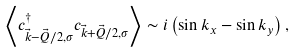<formula> <loc_0><loc_0><loc_500><loc_500>\left \langle c _ { \vec { k } - \vec { Q } / 2 , \sigma } ^ { \dagger } c _ { \vec { k } + \vec { Q } / 2 , \sigma } \right \rangle \sim i \left ( \sin k _ { x } - \sin k _ { y } \right ) ,</formula> 